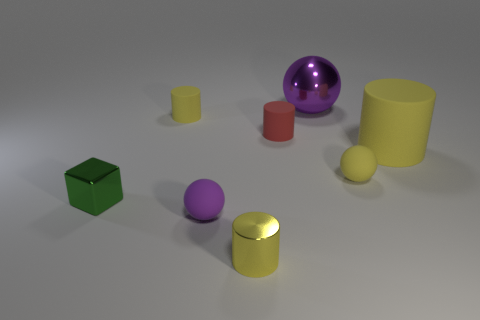What size is the sphere that is in front of the green shiny block?
Offer a very short reply. Small. What number of tiny rubber cylinders are the same color as the small metal cube?
Provide a short and direct response. 0. Is there a purple rubber sphere that is on the left side of the purple thing that is left of the red object?
Your response must be concise. No. Does the large thing that is in front of the big ball have the same color as the tiny ball behind the green block?
Keep it short and to the point. Yes. The metal cylinder that is the same size as the metallic block is what color?
Ensure brevity in your answer.  Yellow. Is the number of green things that are behind the small yellow sphere the same as the number of tiny green cubes on the right side of the cube?
Keep it short and to the point. Yes. What is the material of the red object that is in front of the yellow thing that is behind the large yellow matte thing?
Give a very brief answer. Rubber. How many things are either big shiny objects or small gray shiny spheres?
Provide a short and direct response. 1. What is the size of the other thing that is the same color as the big shiny thing?
Give a very brief answer. Small. Are there fewer large green metal spheres than purple things?
Offer a very short reply. Yes. 